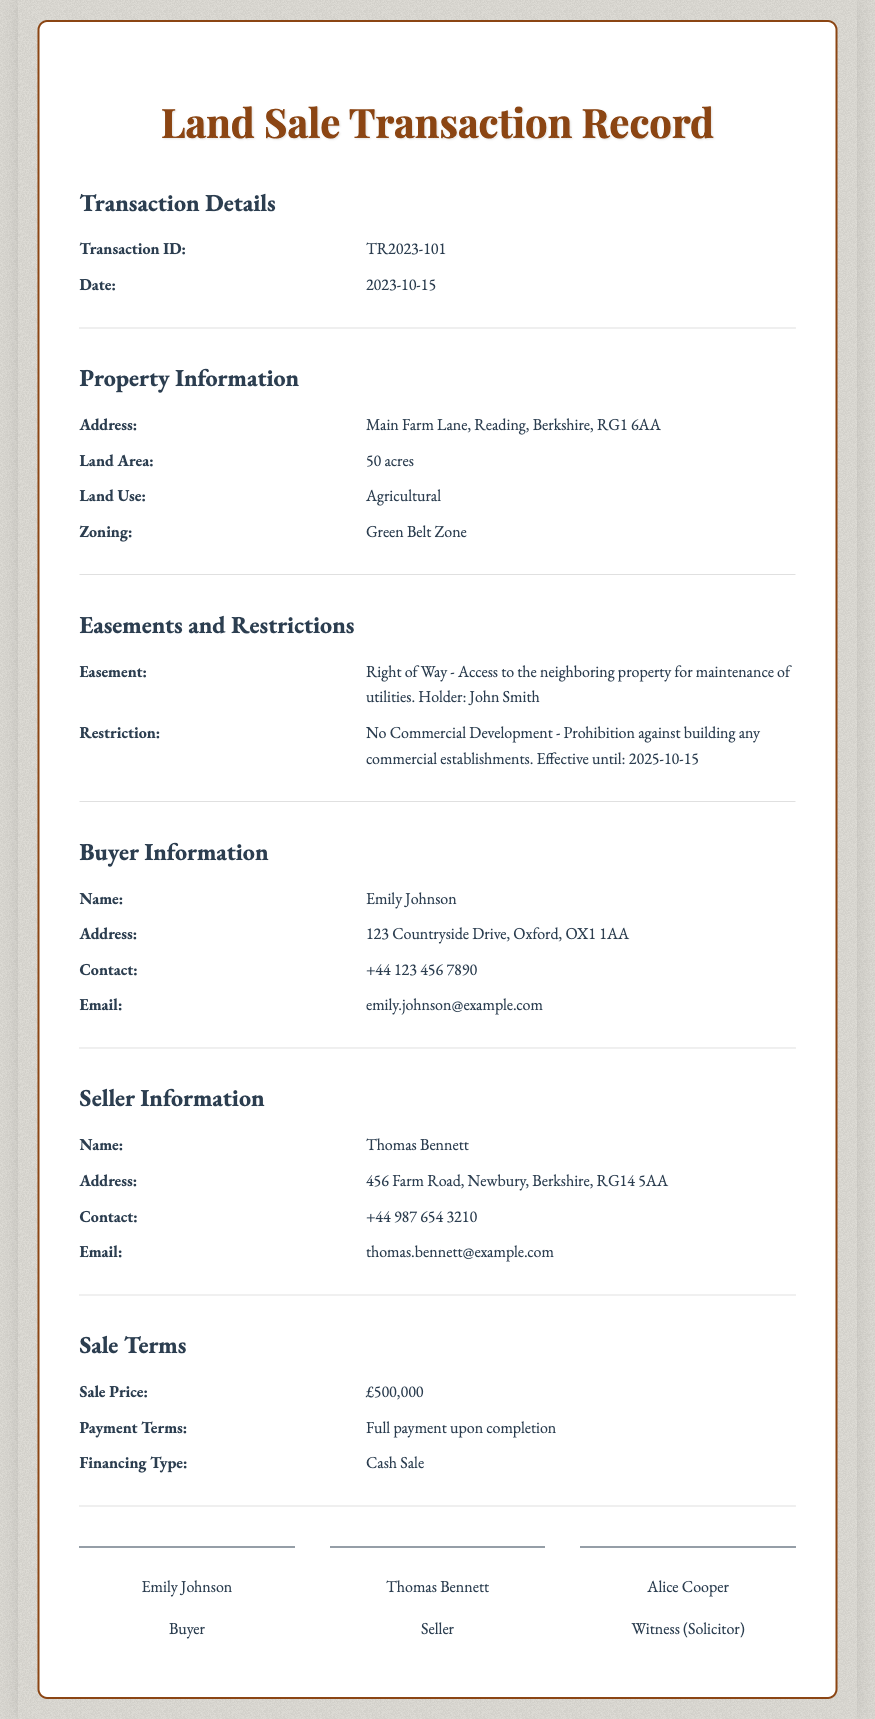What is the transaction ID? The transaction ID is specifically recorded in the document under the transaction details section.
Answer: TR2023-101 Who is the buyer? The buyer's name is listed in the buyer information section of the document.
Answer: Emily Johnson What is the sale price? The sale price is mentioned in the sale terms section of the document.
Answer: £500,000 What is the land area? The land area is specified in the property information section.
Answer: 50 acres What type of easement is mentioned? The easement type is detailed under the easements and restrictions section of the document.
Answer: Right of Way What is the email address of the seller? The seller's email is recorded in the seller information section.
Answer: thomas.bennett@example.com What is the zoning classification of the property? The zoning classification is provided in the property information section.
Answer: Green Belt Zone What is the payment term for the sale? The payment term is explicitly stated in the sale terms section of the document.
Answer: Full payment upon completion What is the restriction in place for the property? The specific restriction related to the property is found under easements and restrictions.
Answer: No Commercial Development When is the restriction effective until? The effective date for the restriction is mentioned in the easements and restrictions section.
Answer: 2025-10-15 